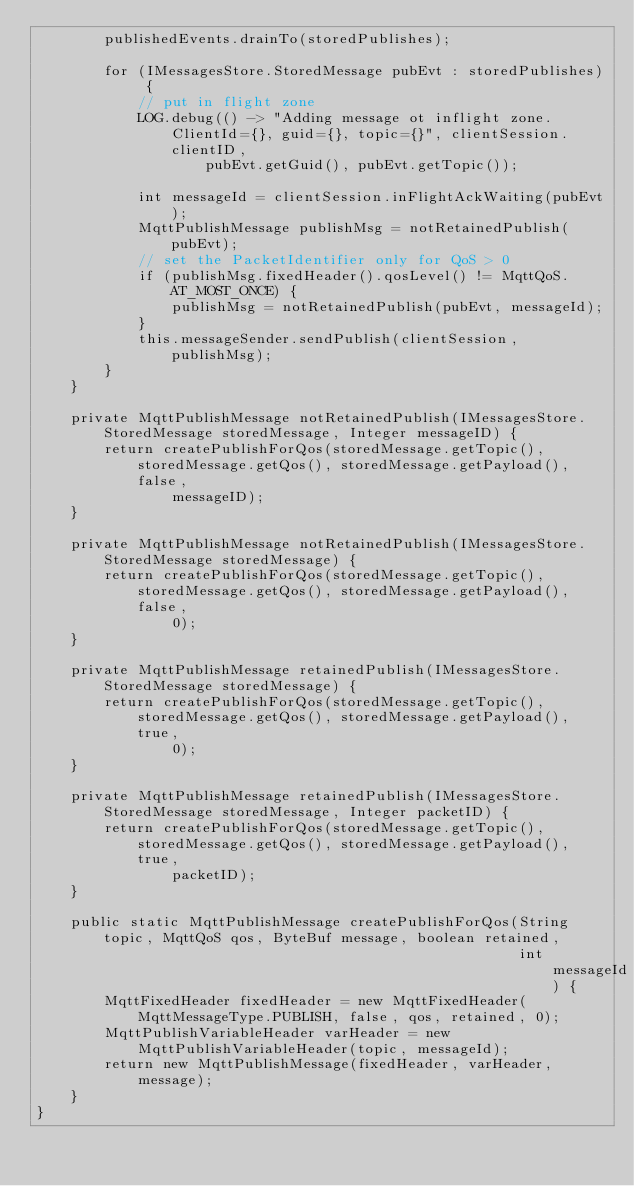<code> <loc_0><loc_0><loc_500><loc_500><_Java_>        publishedEvents.drainTo(storedPublishes);

        for (IMessagesStore.StoredMessage pubEvt : storedPublishes) {
            // put in flight zone
            LOG.debug(() -> "Adding message ot inflight zone. ClientId={}, guid={}, topic={}", clientSession.clientID,
                    pubEvt.getGuid(), pubEvt.getTopic());

            int messageId = clientSession.inFlightAckWaiting(pubEvt);
            MqttPublishMessage publishMsg = notRetainedPublish(pubEvt);
            // set the PacketIdentifier only for QoS > 0
            if (publishMsg.fixedHeader().qosLevel() != MqttQoS.AT_MOST_ONCE) {
                publishMsg = notRetainedPublish(pubEvt, messageId);
            }
            this.messageSender.sendPublish(clientSession, publishMsg);
        }
    }

    private MqttPublishMessage notRetainedPublish(IMessagesStore.StoredMessage storedMessage, Integer messageID) {
        return createPublishForQos(storedMessage.getTopic(), storedMessage.getQos(), storedMessage.getPayload(), false,
                messageID);
    }

    private MqttPublishMessage notRetainedPublish(IMessagesStore.StoredMessage storedMessage) {
        return createPublishForQos(storedMessage.getTopic(), storedMessage.getQos(), storedMessage.getPayload(), false,
                0);
    }

    private MqttPublishMessage retainedPublish(IMessagesStore.StoredMessage storedMessage) {
        return createPublishForQos(storedMessage.getTopic(), storedMessage.getQos(), storedMessage.getPayload(), true,
                0);
    }

    private MqttPublishMessage retainedPublish(IMessagesStore.StoredMessage storedMessage, Integer packetID) {
        return createPublishForQos(storedMessage.getTopic(), storedMessage.getQos(), storedMessage.getPayload(), true,
                packetID);
    }

    public static MqttPublishMessage createPublishForQos(String topic, MqttQoS qos, ByteBuf message, boolean retained,
                                                         int messageId) {
        MqttFixedHeader fixedHeader = new MqttFixedHeader(MqttMessageType.PUBLISH, false, qos, retained, 0);
        MqttPublishVariableHeader varHeader = new MqttPublishVariableHeader(topic, messageId);
        return new MqttPublishMessage(fixedHeader, varHeader, message);
    }
}
</code> 